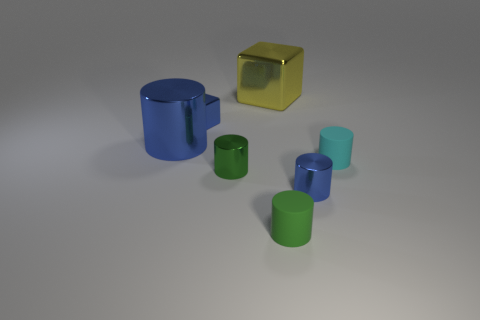Subtract all cyan cylinders. How many cylinders are left? 4 Subtract all green balls. How many blue cylinders are left? 2 Subtract 2 cylinders. How many cylinders are left? 3 Subtract all blue cylinders. How many cylinders are left? 3 Add 1 cylinders. How many objects exist? 8 Subtract all cubes. How many objects are left? 5 Subtract all green blocks. Subtract all green cylinders. How many blocks are left? 2 Subtract all blocks. Subtract all shiny objects. How many objects are left? 0 Add 2 big metal things. How many big metal things are left? 4 Add 6 blue objects. How many blue objects exist? 9 